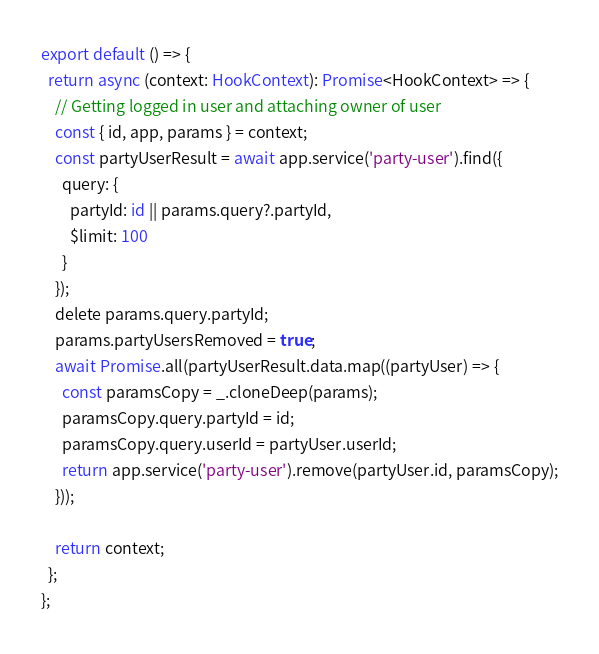<code> <loc_0><loc_0><loc_500><loc_500><_TypeScript_>export default () => {
  return async (context: HookContext): Promise<HookContext> => {
    // Getting logged in user and attaching owner of user
    const { id, app, params } = context;
    const partyUserResult = await app.service('party-user').find({
      query: {
        partyId: id || params.query?.partyId,
        $limit: 100
      }
    });
    delete params.query.partyId;
    params.partyUsersRemoved = true;
    await Promise.all(partyUserResult.data.map((partyUser) => {
      const paramsCopy = _.cloneDeep(params);
      paramsCopy.query.partyId = id;
      paramsCopy.query.userId = partyUser.userId;
      return app.service('party-user').remove(partyUser.id, paramsCopy);
    }));

    return context;
  };
};
</code> 